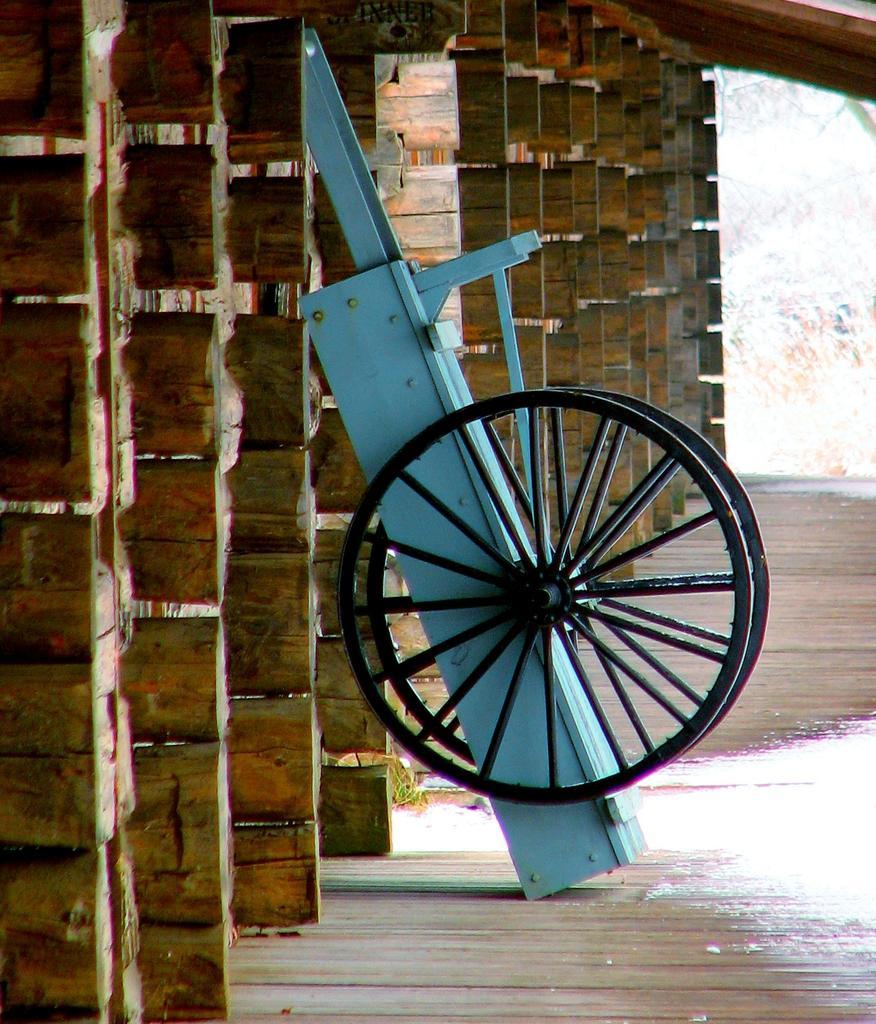Please provide a concise description of this image. There is a wheel cart in the image. The floor and wall is made of wood. 